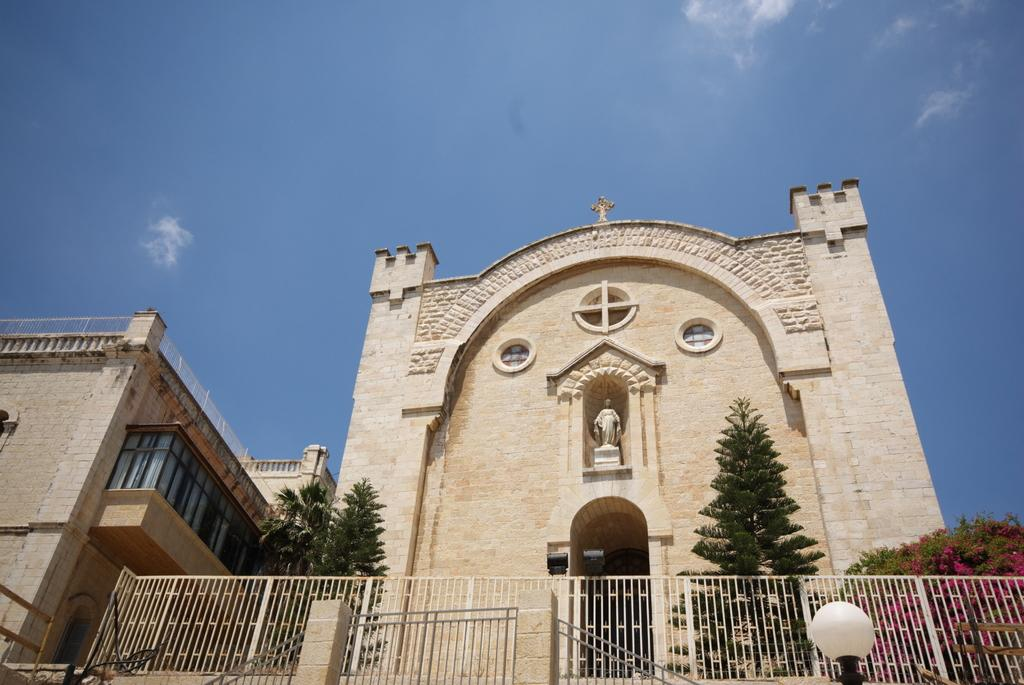What type of structures can be seen in the image? There are buildings in the image, including a church. What is in front of the church? There is a fencing in front of the church. What type of vegetation is present in the image? There are trees in the image. What type of songs can be heard coming from the church in the image? There is no indication in the image that any songs are being played or sung in the church. What effect does the fencing have on the skin of the people in the image? There are no people present in the image, so it is impossible to determine any effect the fencing might have on their skin. 